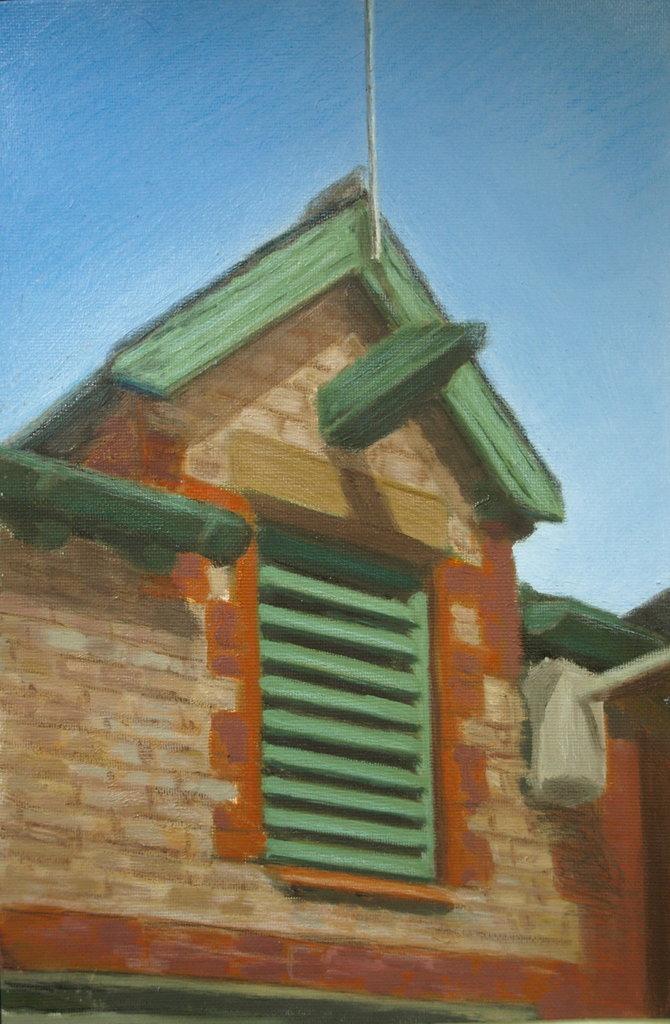Can you describe this image briefly? In this image, we can see a painting of a house and the background is in blue color. 